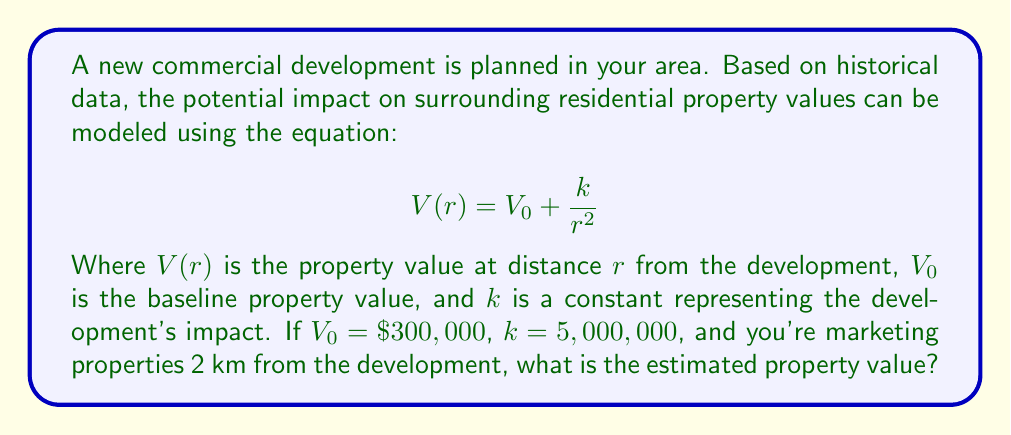Can you answer this question? To solve this problem, we'll follow these steps:

1) We're given the equation for the potential impact on property values:
   $$V(r) = V_0 + \frac{k}{r^2}$$

2) We know the following values:
   $V_0 = \$300,000$ (baseline property value)
   $k = 5,000,000$ (impact constant)
   $r = 2$ km (distance from development)

3) Let's substitute these values into our equation:
   $$V(2) = 300,000 + \frac{5,000,000}{2^2}$$

4) Simplify the denominator:
   $$V(2) = 300,000 + \frac{5,000,000}{4}$$

5) Perform the division:
   $$V(2) = 300,000 + 1,250,000$$

6) Add the results:
   $$V(2) = 1,550,000$$

Therefore, the estimated property value 2 km from the development is $1,550,000.
Answer: $1,550,000 